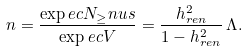<formula> <loc_0><loc_0><loc_500><loc_500>n = \frac { \exp e c { N _ { \geq } n u s } } { \exp e c { V } } = \frac { h _ { r e n } ^ { 2 } } { 1 - h _ { r e n } ^ { 2 } } \, \Lambda .</formula> 